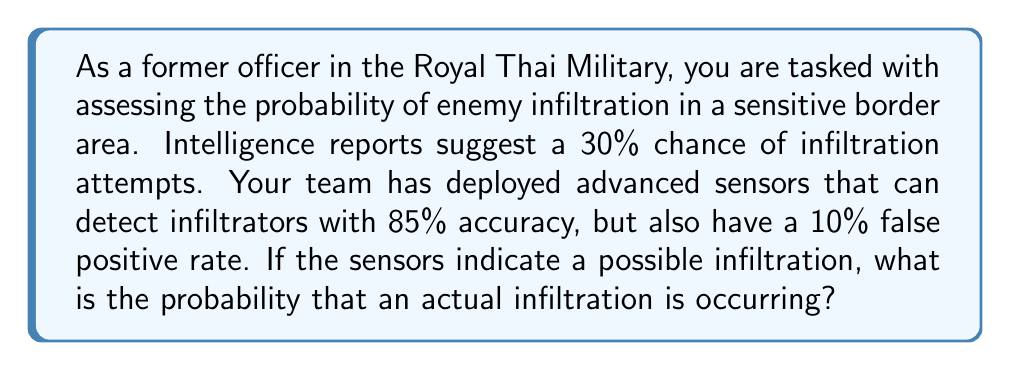Show me your answer to this math problem. To solve this problem, we'll use Bayes' Theorem. Let's define our events:

A: Actual infiltration occurring
B: Sensors indicate infiltration

Given:
P(A) = 0.30 (prior probability of infiltration)
P(B|A) = 0.85 (true positive rate)
P(B|not A) = 0.10 (false positive rate)

We want to find P(A|B), the probability of an actual infiltration given that the sensors indicate one.

Bayes' Theorem states:

$$ P(A|B) = \frac{P(B|A) \cdot P(A)}{P(B)} $$

To find P(B), we use the law of total probability:

$$ P(B) = P(B|A) \cdot P(A) + P(B|not A) \cdot P(not A) $$

$$ P(B) = 0.85 \cdot 0.30 + 0.10 \cdot 0.70 = 0.255 + 0.07 = 0.325 $$

Now we can apply Bayes' Theorem:

$$ P(A|B) = \frac{0.85 \cdot 0.30}{0.325} = \frac{0.255}{0.325} \approx 0.7846 $$

Therefore, the probability of an actual infiltration occurring, given that the sensors indicate one, is approximately 0.7846 or 78.46%.
Answer: The probability of an actual enemy infiltration occurring, given that the sensors indicate one, is approximately 0.7846 or 78.46%. 